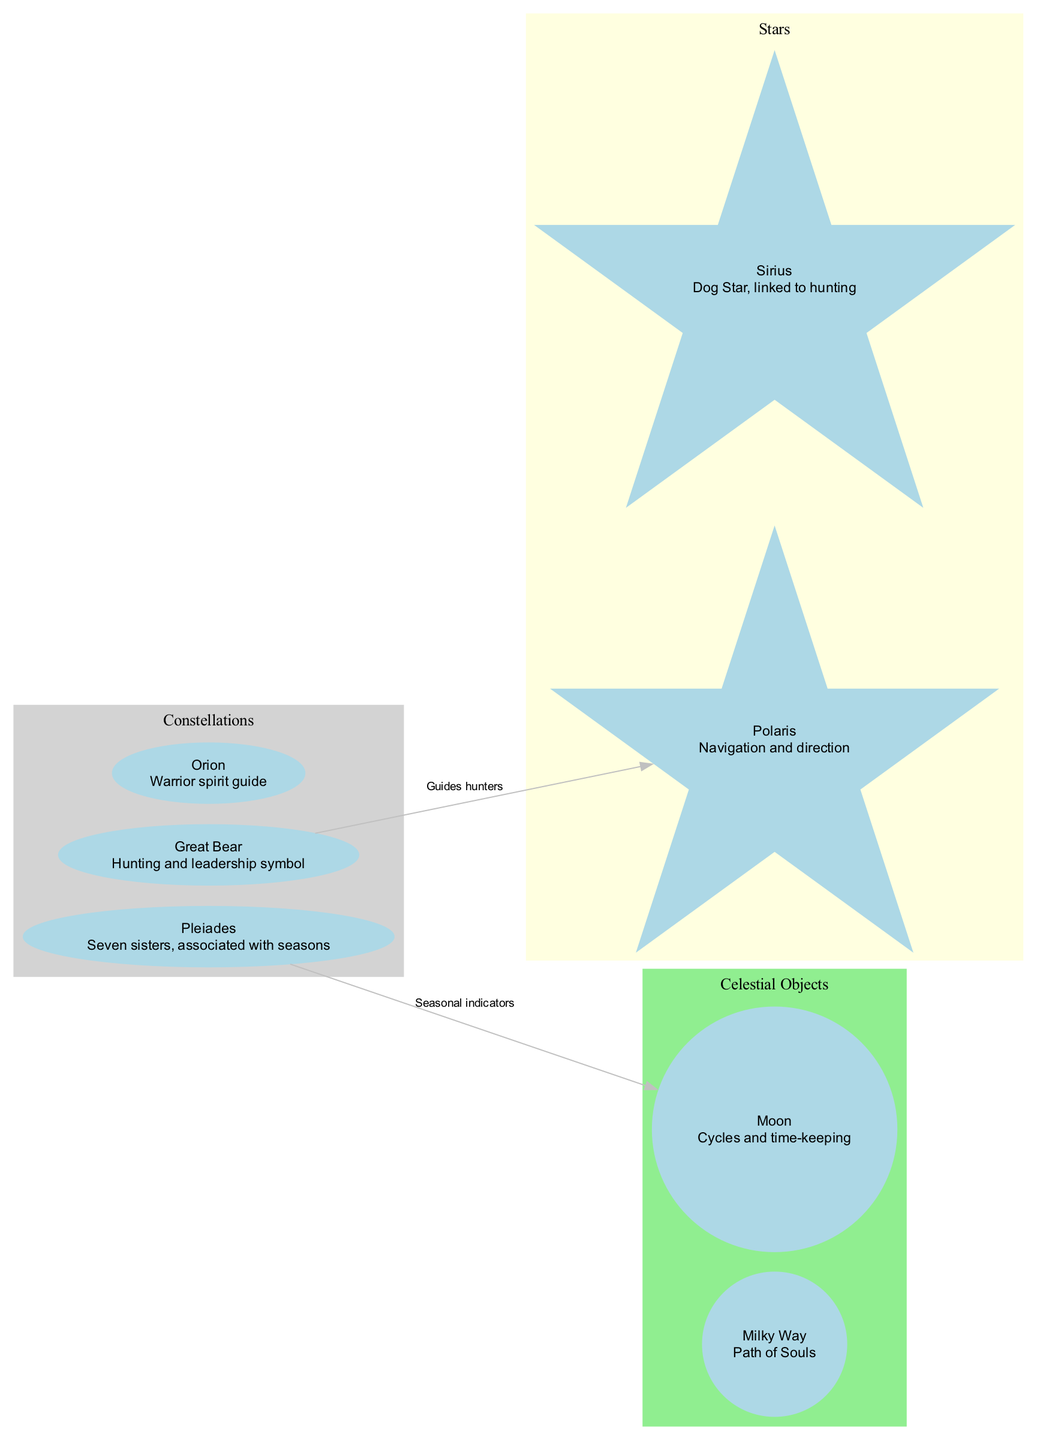What is the significance of the Great Bear? The diagram specifies that the Great Bear is a "Hunting and leadership symbol." This can be found within the constellation information provided in the diagram.
Answer: Hunting and leadership symbol How many constellations are displayed in the diagram? By counting the constellations listed in the diagram, we find there are three: Great Bear, Pleiades, and Orion. The total is therefore three.
Answer: 3 Which star is linked to hunting? According to the diagram, Sirius is identified as the "Dog Star, linked to hunting." This specific information can be found in the star section of the diagram.
Answer: Sirius What celestial object is described as the "Path of Souls"? The diagram indicates that the Milky Way is referred to as the "Path of Souls." This identification is part of the celestial objects provided in the diagram.
Answer: Milky Way What is the relationship between the Pleiades and the Moon? The connections information states that the Pleiades serves as "Seasonal indicators" for the Moon, indicating a directional relationship that indicates a special connection.
Answer: Seasonal indicators Which star guides hunters? The diagram shows that Polaris has the label "Guides hunters," indicating its significance in helping navigate while hunting.
Answer: Polaris How many connections are shown in the diagram? The diagram displays two labeled connections, which are the connections from Great Bear to Polaris and from Pleiades to Moon. Therefore, there are two connections in total.
Answer: 2 What significance is associated with Orion? The diagram specifies that Orion is recognized as a "Warrior spirit guide," meaning it has profound interpretive value in the sky according to the represented mythology.
Answer: Warrior spirit guide What do the Pleiades indicate in terms of cycles? The Pleiades are associated specifically with seasonal indicators, which suggests their intrinsic connection to changes in the natural world and cycles of the seasons as per the diagram.
Answer: Seasonal indicators 